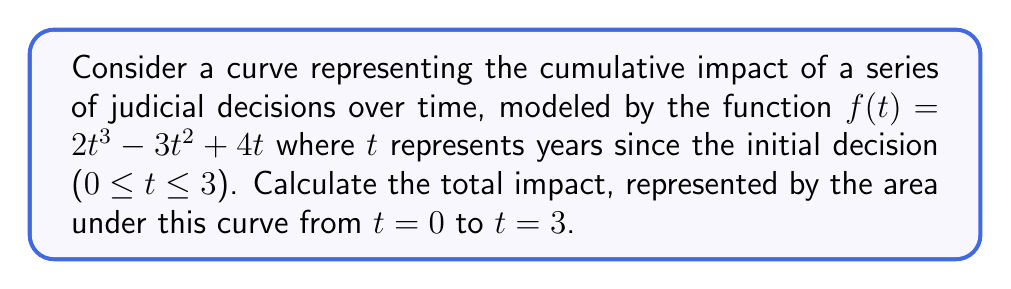What is the answer to this math problem? To find the area under the curve, we need to calculate the definite integral of $f(t)$ from $t=0$ to $t=3$. Let's proceed step-by-step:

1) The function is $f(t) = 2t^3 - 3t^2 + 4t$

2) We need to find $\int_0^3 (2t^3 - 3t^2 + 4t) dt$

3) Integrate each term:
   $$\int 2t^3 dt = \frac{1}{2}t^4$$
   $$\int -3t^2 dt = -t^3$$
   $$\int 4t dt = 2t^2$$

4) The antiderivative is:
   $$F(t) = \frac{1}{2}t^4 - t^3 + 2t^2 + C$$

5) Apply the fundamental theorem of calculus:
   $$\int_0^3 f(t) dt = F(3) - F(0)$$

6) Calculate $F(3)$:
   $$F(3) = \frac{1}{2}(3^4) - (3^3) + 2(3^2) = 40.5 - 27 + 18 = 31.5$$

7) Calculate $F(0)$:
   $$F(0) = \frac{1}{2}(0^4) - (0^3) + 2(0^2) = 0$$

8) Subtract:
   $$F(3) - F(0) = 31.5 - 0 = 31.5$$

Therefore, the total impact, represented by the area under the curve from $t=0$ to $t=3$, is 31.5 units.
Answer: 31.5 units 